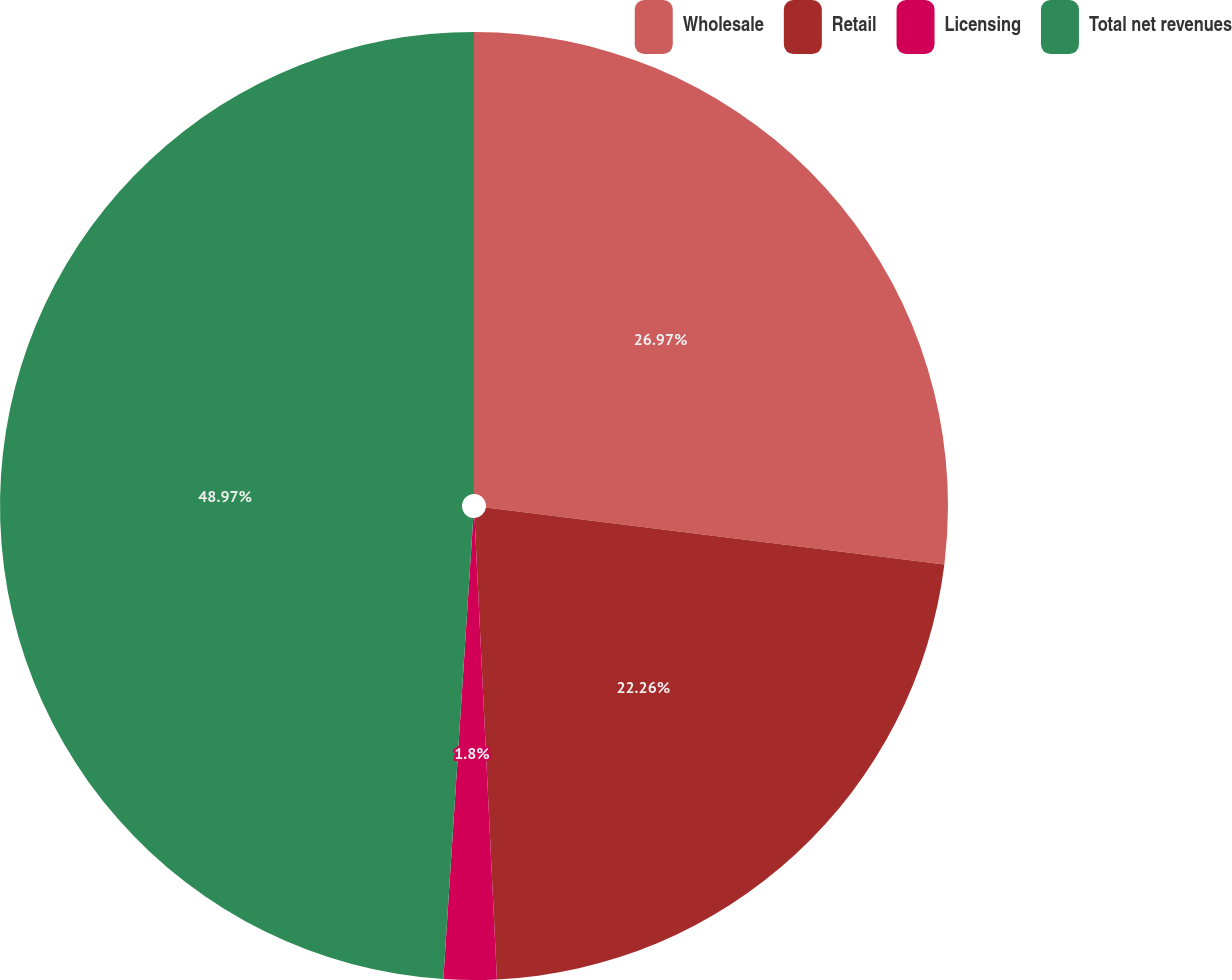Convert chart. <chart><loc_0><loc_0><loc_500><loc_500><pie_chart><fcel>Wholesale<fcel>Retail<fcel>Licensing<fcel>Total net revenues<nl><fcel>26.97%<fcel>22.26%<fcel>1.8%<fcel>48.97%<nl></chart> 